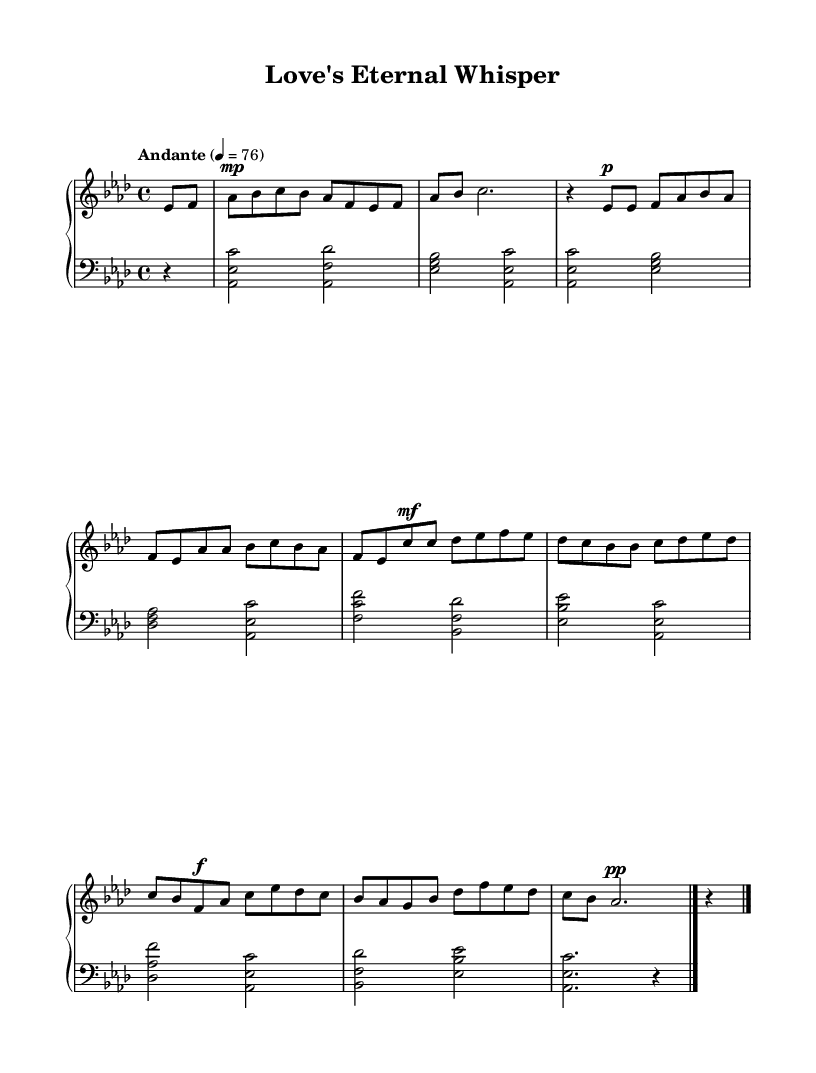What is the key signature of this music? The key signature is indicated by the sharps or flats present at the beginning of the staff. The presence of four sharps corresponds to the key of A flat major.
Answer: A flat major What is the time signature of this music? The time signature is presented at the beginning and is determined by the numbers indicating beats per measure. The numbers "4/4" indicate that there are four beats per measure, with a quarter note receiving one beat.
Answer: 4/4 What is the tempo marking for this piece? The tempo marking indicates the speed of the music and is given above the staff. The marking "Andante" suggests a moderate pace, and the metronome marking "4 = 76" specifies that there should be 76 quarter note beats per minute.
Answer: Andante How many distinct sections are there in this piece? By analyzing the musical structure, we see an Intro, Verse, Chorus, Bridge, and Outro, indicating a total of five distinct sections in the composition.
Answer: 5 Which dynamic marking indicates the loudest point in the music? The dynamic markings indicate variations in volume throughout the piece. The marking "f" (forte) appears in the Bridge section, which indicates this is where the music reaches its loudest.
Answer: f What is the last chord of the piece? By examining the final measures of the music, the last chord is identified visually as the notes A flat, E flat, and C played together, indicated by the chord symbol.
Answer: A flat major 